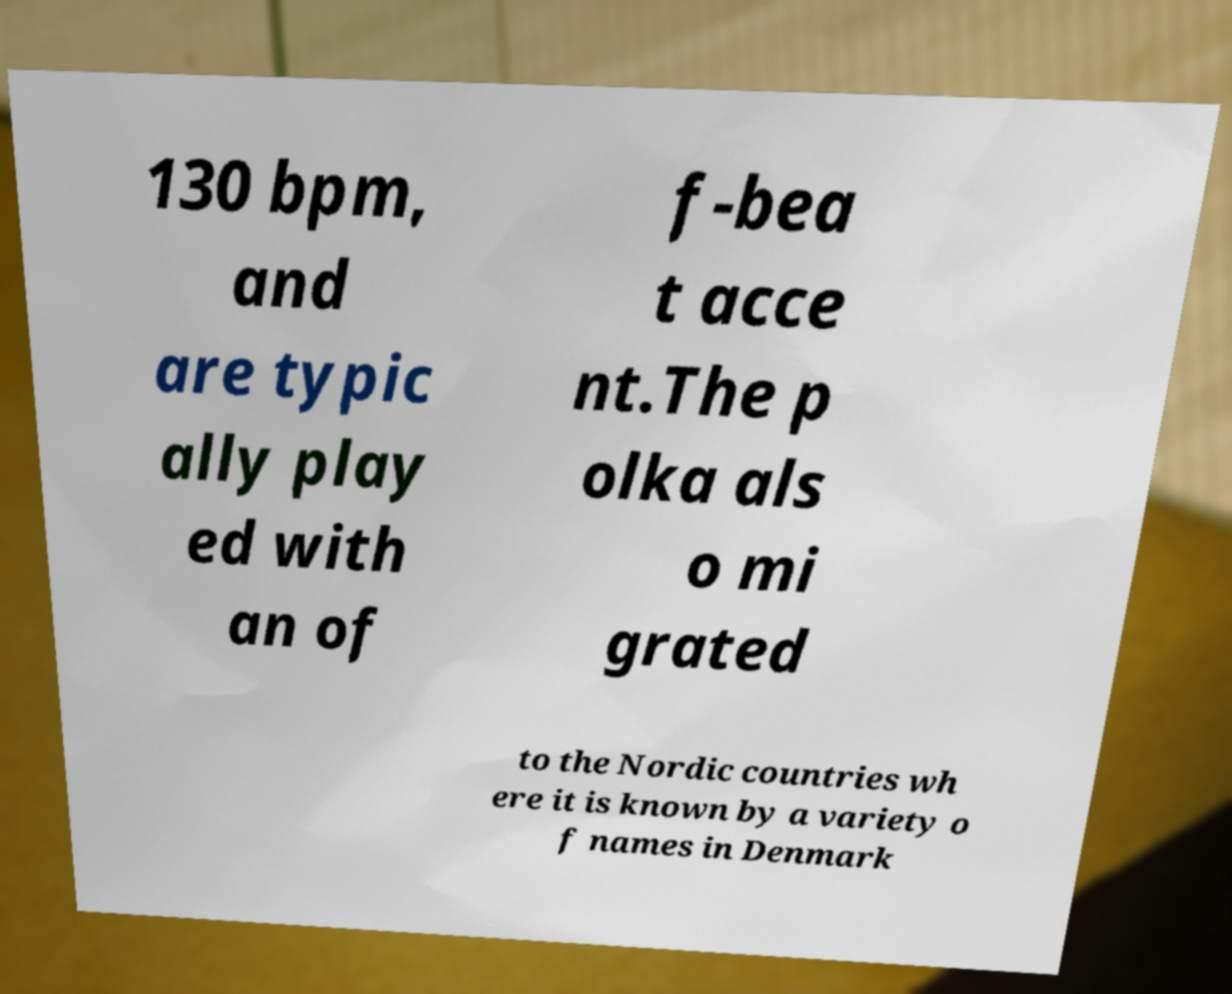Please read and relay the text visible in this image. What does it say? 130 bpm, and are typic ally play ed with an of f-bea t acce nt.The p olka als o mi grated to the Nordic countries wh ere it is known by a variety o f names in Denmark 